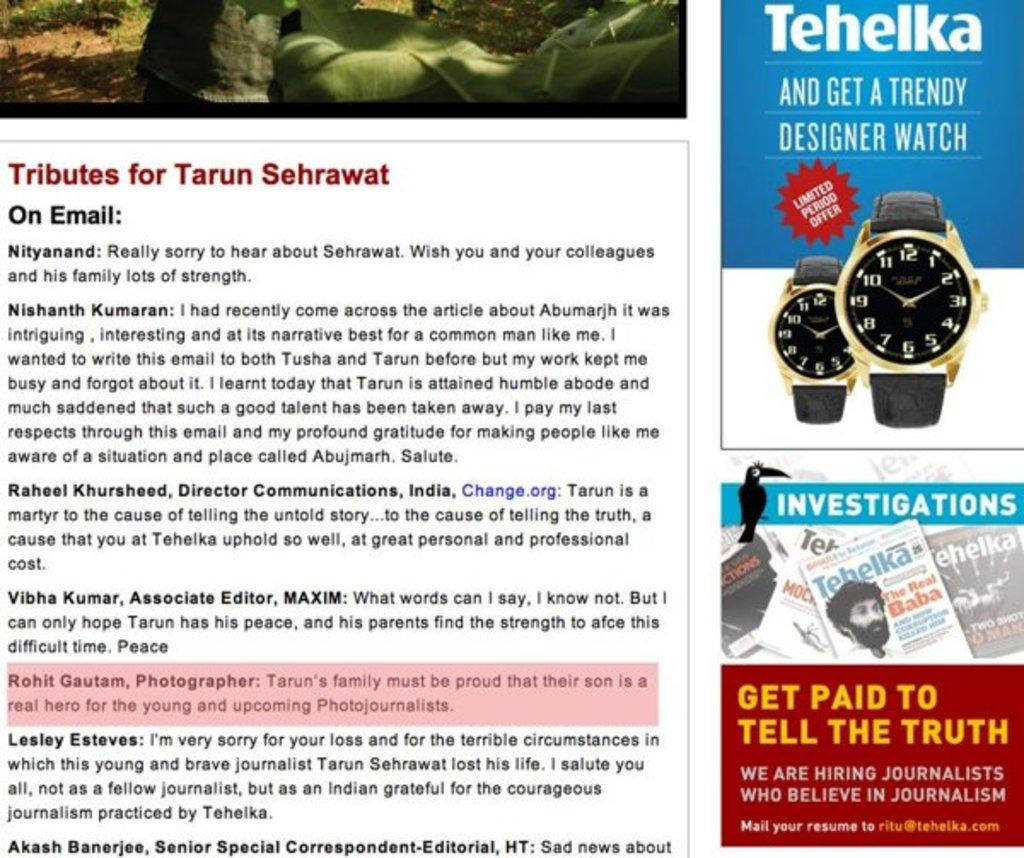<image>
Describe the image concisely. A page from a magazine which contains various written tributes to someone called Tarun Sehrawat. 